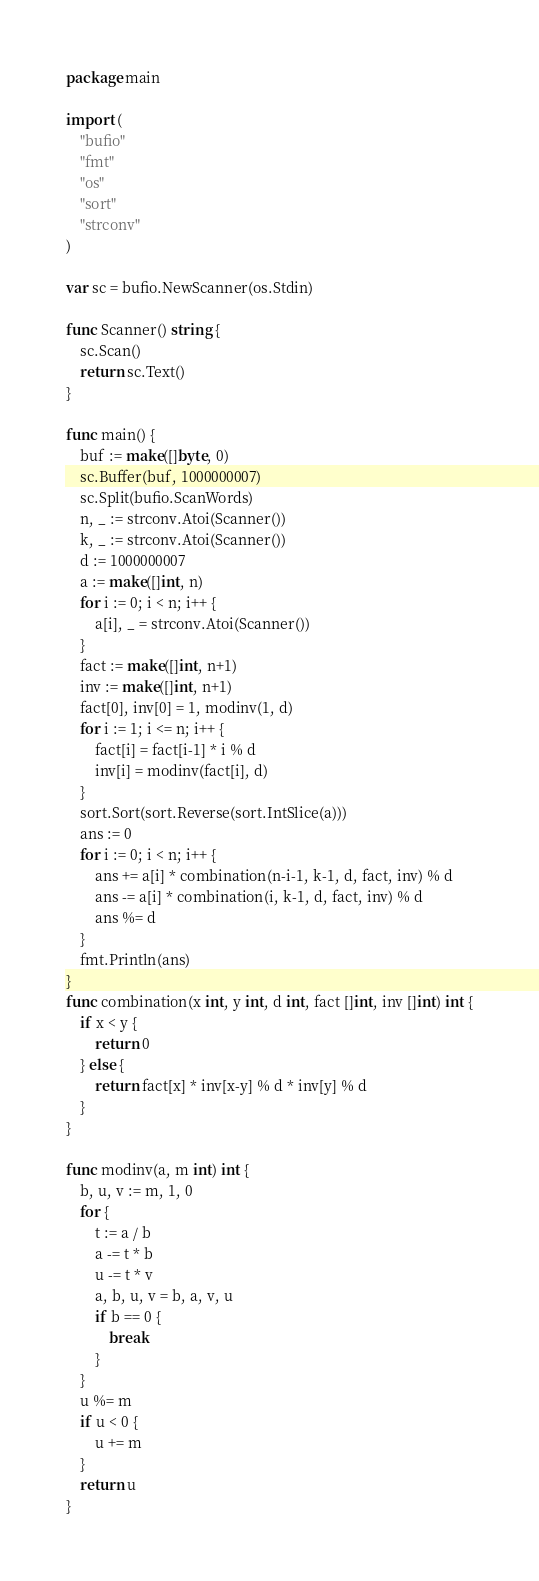<code> <loc_0><loc_0><loc_500><loc_500><_Go_>package main

import (
	"bufio"
	"fmt"
	"os"
	"sort"
	"strconv"
)

var sc = bufio.NewScanner(os.Stdin)

func Scanner() string {
	sc.Scan()
	return sc.Text()
}

func main() {
	buf := make([]byte, 0)
	sc.Buffer(buf, 1000000007)
	sc.Split(bufio.ScanWords)
	n, _ := strconv.Atoi(Scanner())
	k, _ := strconv.Atoi(Scanner())
	d := 1000000007
	a := make([]int, n)
	for i := 0; i < n; i++ {
		a[i], _ = strconv.Atoi(Scanner())
	}
	fact := make([]int, n+1)
	inv := make([]int, n+1)
	fact[0], inv[0] = 1, modinv(1, d)
	for i := 1; i <= n; i++ {
		fact[i] = fact[i-1] * i % d
		inv[i] = modinv(fact[i], d)
	}
	sort.Sort(sort.Reverse(sort.IntSlice(a)))
	ans := 0
	for i := 0; i < n; i++ {
		ans += a[i] * combination(n-i-1, k-1, d, fact, inv) % d
		ans -= a[i] * combination(i, k-1, d, fact, inv) % d
		ans %= d
	}
	fmt.Println(ans)
}
func combination(x int, y int, d int, fact []int, inv []int) int {
	if x < y {
		return 0
	} else {
		return fact[x] * inv[x-y] % d * inv[y] % d
	}
}

func modinv(a, m int) int {
	b, u, v := m, 1, 0
	for {
		t := a / b
		a -= t * b
		u -= t * v
		a, b, u, v = b, a, v, u
		if b == 0 {
			break
		}
	}
	u %= m
	if u < 0 {
		u += m
	}
	return u
}
</code> 